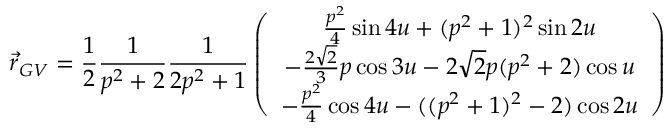<formula> <loc_0><loc_0><loc_500><loc_500>\vec { r } _ { G V } = { \frac { 1 } { 2 } } { \frac { 1 } { p ^ { 2 } + 2 } } { \frac { 1 } { 2 p ^ { 2 } + 1 } } \left ( \begin{array} { c } { { { \frac { p ^ { 2 } } { 4 } } \sin { 4 u } + ( p ^ { 2 } + 1 ) ^ { 2 } \sin { 2 u } } } \\ { { - { \frac { 2 \sqrt { 2 } } { 3 } } p \cos { 3 u } - 2 \sqrt { 2 } p ( p ^ { 2 } + 2 ) \cos { u } } } \\ { { - { \frac { p ^ { 2 } } { 4 } } \cos { 4 u } - ( ( p ^ { 2 } + 1 ) ^ { 2 } - 2 ) \cos { 2 u } } } \end{array} \right )</formula> 